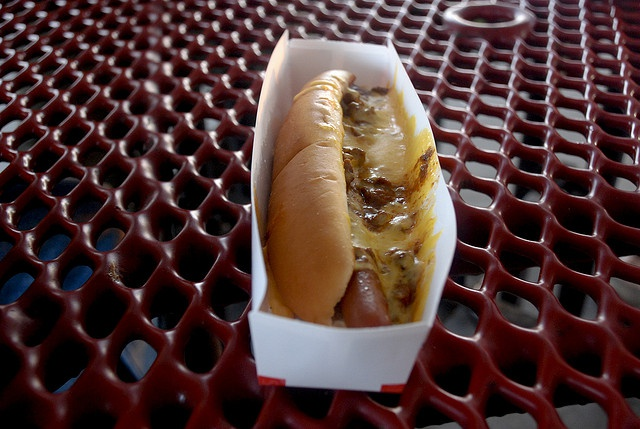Describe the objects in this image and their specific colors. I can see a hot dog in black, maroon, brown, and gray tones in this image. 